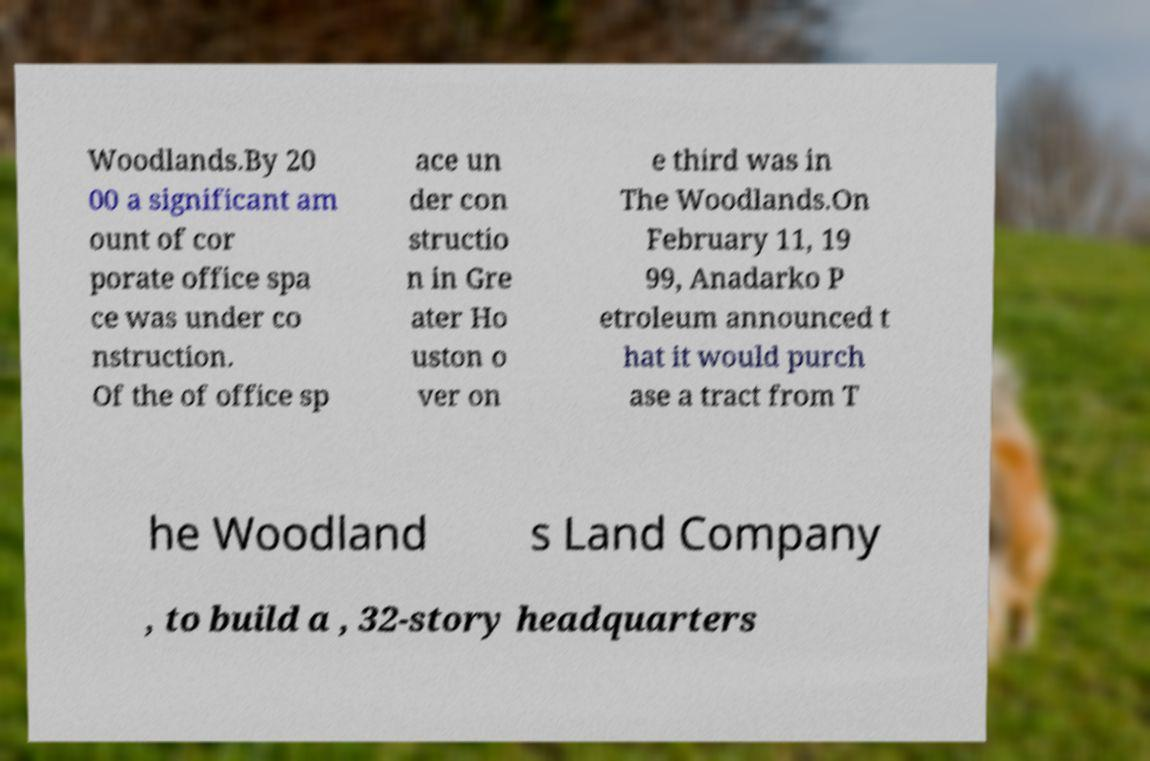Could you extract and type out the text from this image? Woodlands.By 20 00 a significant am ount of cor porate office spa ce was under co nstruction. Of the of office sp ace un der con structio n in Gre ater Ho uston o ver on e third was in The Woodlands.On February 11, 19 99, Anadarko P etroleum announced t hat it would purch ase a tract from T he Woodland s Land Company , to build a , 32-story headquarters 